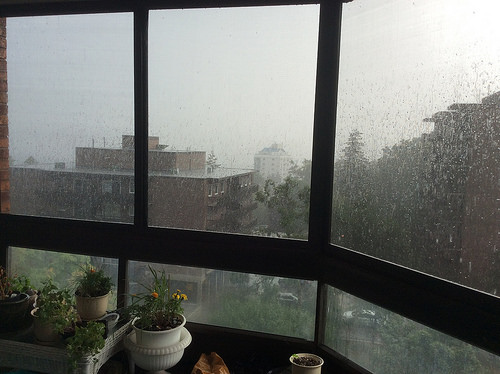<image>
Is the sky behind the glass? Yes. From this viewpoint, the sky is positioned behind the glass, with the glass partially or fully occluding the sky. 